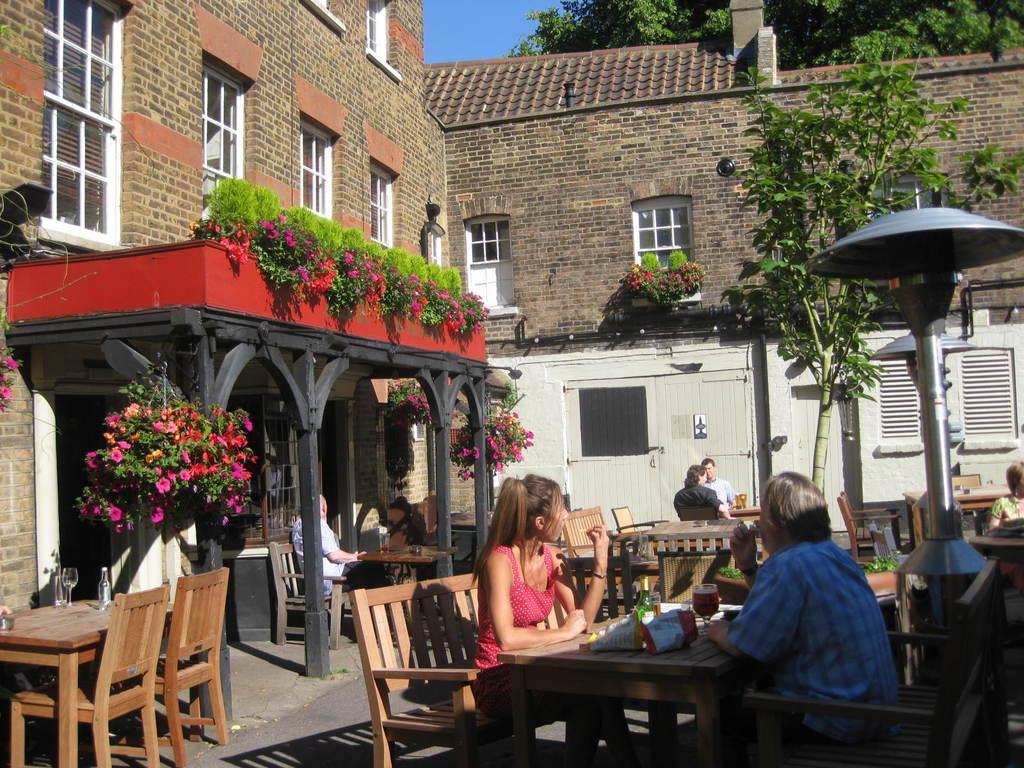Could you give a brief overview of what you see in this image? The picture is clicked outside of a building,there are dining tables and chairs and people sat on it. The arch has plant flowers,this seems to be outside hotel area. 